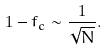<formula> <loc_0><loc_0><loc_500><loc_500>1 - f _ { c } \sim \frac { 1 } { \sqrt { N } } .</formula> 